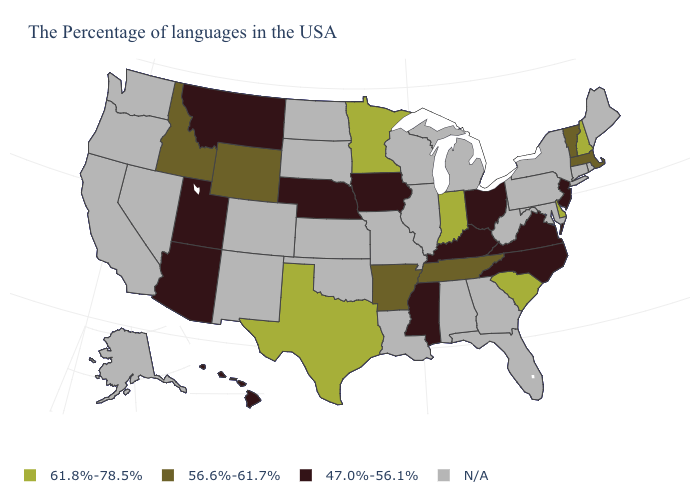What is the value of New York?
Give a very brief answer. N/A. Name the states that have a value in the range N/A?
Be succinct. Maine, Rhode Island, Connecticut, New York, Maryland, Pennsylvania, West Virginia, Florida, Georgia, Michigan, Alabama, Wisconsin, Illinois, Louisiana, Missouri, Kansas, Oklahoma, South Dakota, North Dakota, Colorado, New Mexico, Nevada, California, Washington, Oregon, Alaska. Name the states that have a value in the range 47.0%-56.1%?
Quick response, please. New Jersey, Virginia, North Carolina, Ohio, Kentucky, Mississippi, Iowa, Nebraska, Utah, Montana, Arizona, Hawaii. What is the value of New York?
Be succinct. N/A. What is the value of Missouri?
Short answer required. N/A. Among the states that border Wisconsin , does Iowa have the highest value?
Keep it brief. No. What is the lowest value in the USA?
Short answer required. 47.0%-56.1%. Does Indiana have the lowest value in the MidWest?
Give a very brief answer. No. What is the lowest value in the South?
Concise answer only. 47.0%-56.1%. Name the states that have a value in the range 61.8%-78.5%?
Keep it brief. New Hampshire, Delaware, South Carolina, Indiana, Minnesota, Texas. What is the value of New York?
Write a very short answer. N/A. Name the states that have a value in the range 47.0%-56.1%?
Give a very brief answer. New Jersey, Virginia, North Carolina, Ohio, Kentucky, Mississippi, Iowa, Nebraska, Utah, Montana, Arizona, Hawaii. 